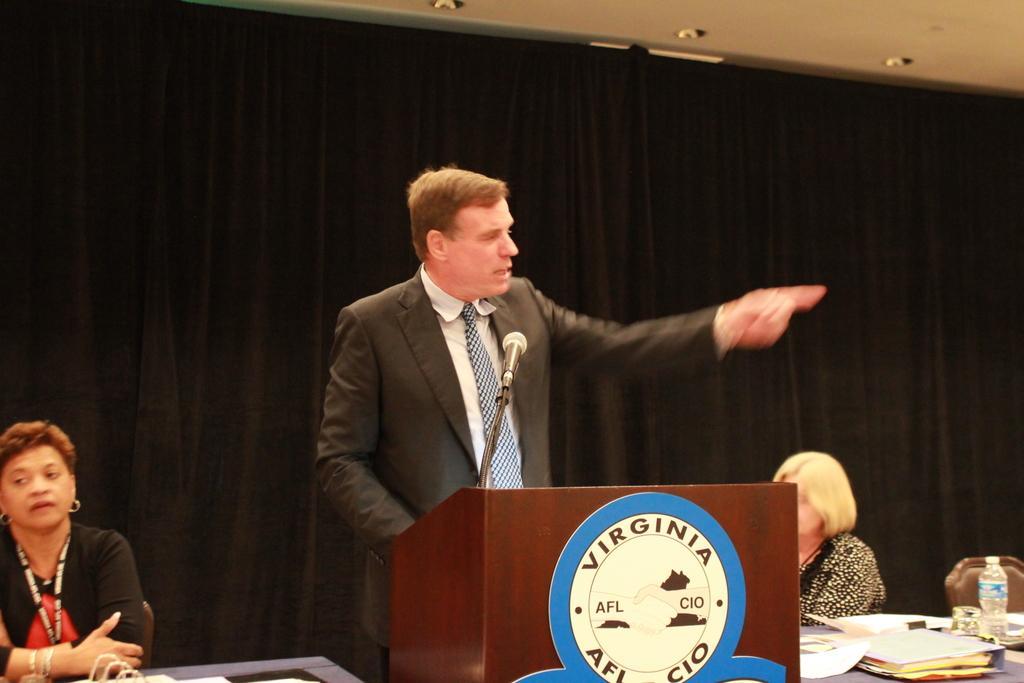Could you give a brief overview of what you see in this image? In this image we can see a person standing near a podium. To the left side of the image there is a lady sitting on a chair. To the right side of the image there is another lady sitting on chair. In front of her there is a table on which there are papers, water bottle and glass. In the background of the image there is black color curtain. At the top of the image there is ceiling. 